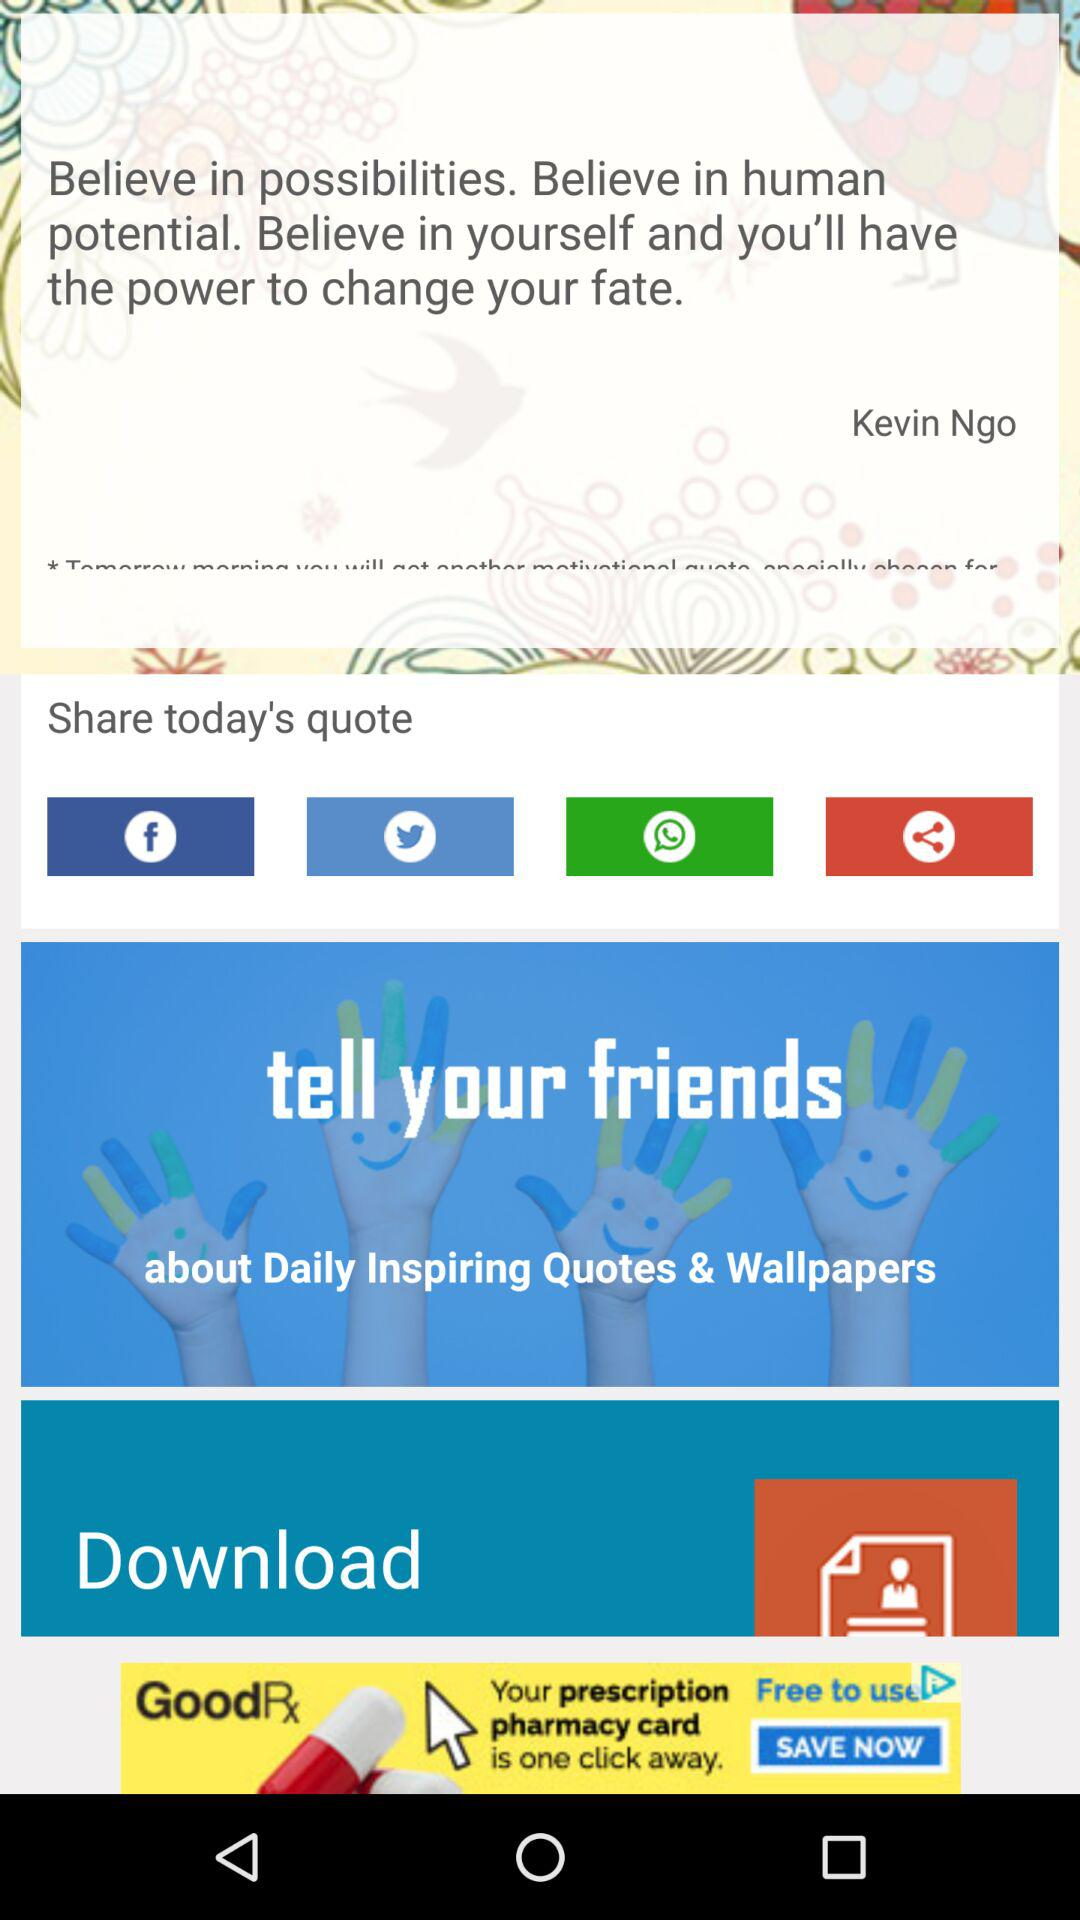Which options can be used to share the quote? The options that can be used to share the quote are "Facebook", "Twitter", "WhatsApp" and "Share". 